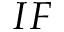<formula> <loc_0><loc_0><loc_500><loc_500>I F</formula> 